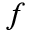Convert formula to latex. <formula><loc_0><loc_0><loc_500><loc_500>f</formula> 